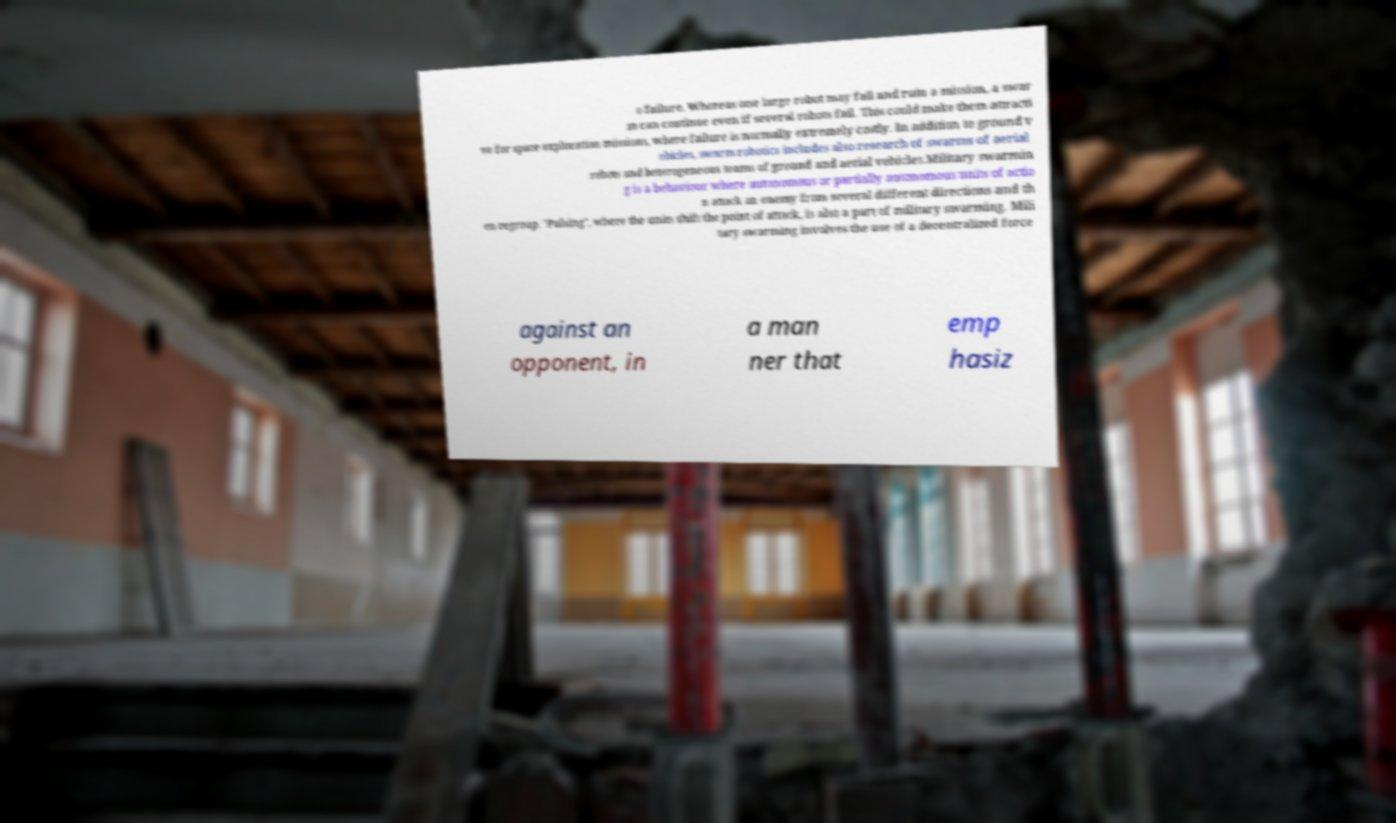Please read and relay the text visible in this image. What does it say? o failure. Whereas one large robot may fail and ruin a mission, a swar m can continue even if several robots fail. This could make them attracti ve for space exploration missions, where failure is normally extremely costly. In addition to ground v ehicles, swarm robotics includes also research of swarms of aerial robots and heterogeneous teams of ground and aerial vehicles.Military swarmin g is a behaviour where autonomous or partially autonomous units of actio n attack an enemy from several different directions and th en regroup. "Pulsing", where the units shift the point of attack, is also a part of military swarming. Mili tary swarming involves the use of a decentralized force against an opponent, in a man ner that emp hasiz 